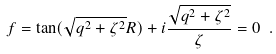Convert formula to latex. <formula><loc_0><loc_0><loc_500><loc_500>f = \tan ( \sqrt { q ^ { 2 } + \zeta ^ { 2 } } R ) + i \frac { \sqrt { q ^ { 2 } + \zeta ^ { 2 } } } { \zeta } = 0 \ .</formula> 